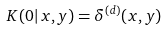Convert formula to latex. <formula><loc_0><loc_0><loc_500><loc_500>K ( 0 | \, x , y ) = \delta ^ { ( d ) } ( x , y )</formula> 